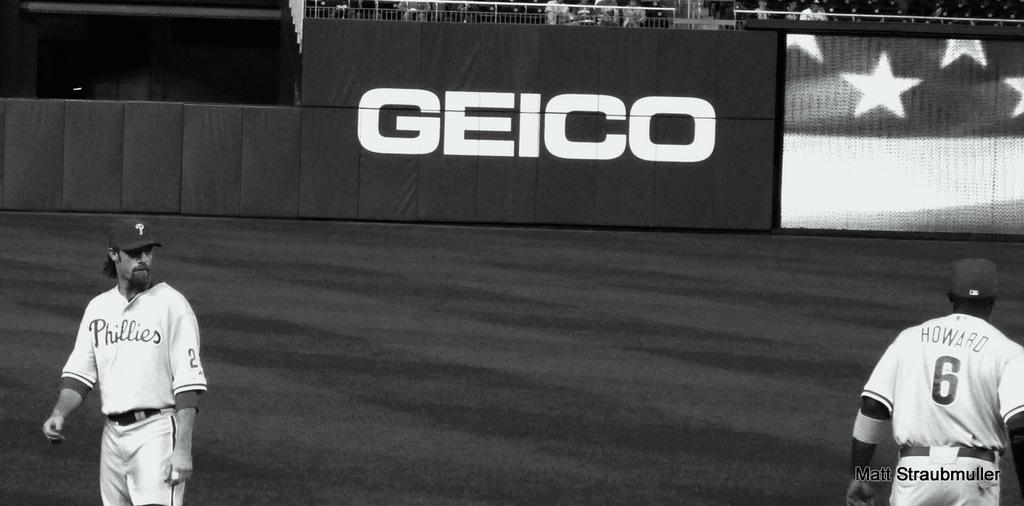<image>
Describe the image concisely. a baseball game with a large Geico ad 